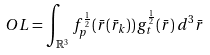<formula> <loc_0><loc_0><loc_500><loc_500>O L = \int _ { \mathbb { R } ^ { 3 } } f _ { p } ^ { \frac { 1 } { 2 } } ( \bar { r } ( \bar { r } _ { k } ) ) \, g _ { t } ^ { \frac { 1 } { 2 } } ( \bar { r } ) \, d ^ { 3 } \bar { r }</formula> 